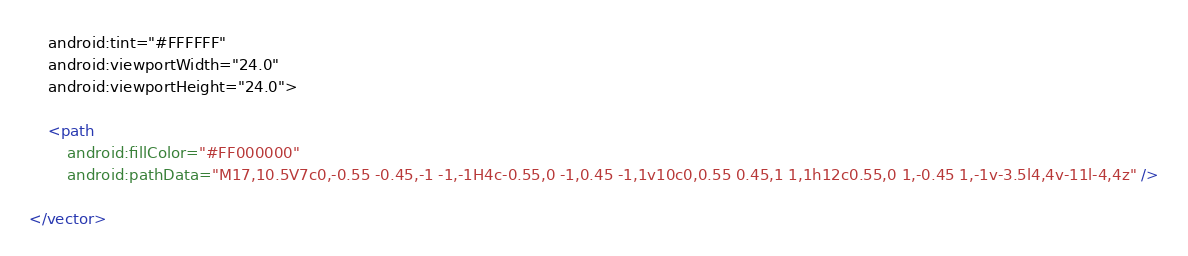<code> <loc_0><loc_0><loc_500><loc_500><_XML_>    android:tint="#FFFFFF"
    android:viewportWidth="24.0"
    android:viewportHeight="24.0">

    <path
        android:fillColor="#FF000000"
        android:pathData="M17,10.5V7c0,-0.55 -0.45,-1 -1,-1H4c-0.55,0 -1,0.45 -1,1v10c0,0.55 0.45,1 1,1h12c0.55,0 1,-0.45 1,-1v-3.5l4,4v-11l-4,4z" />

</vector>
</code> 